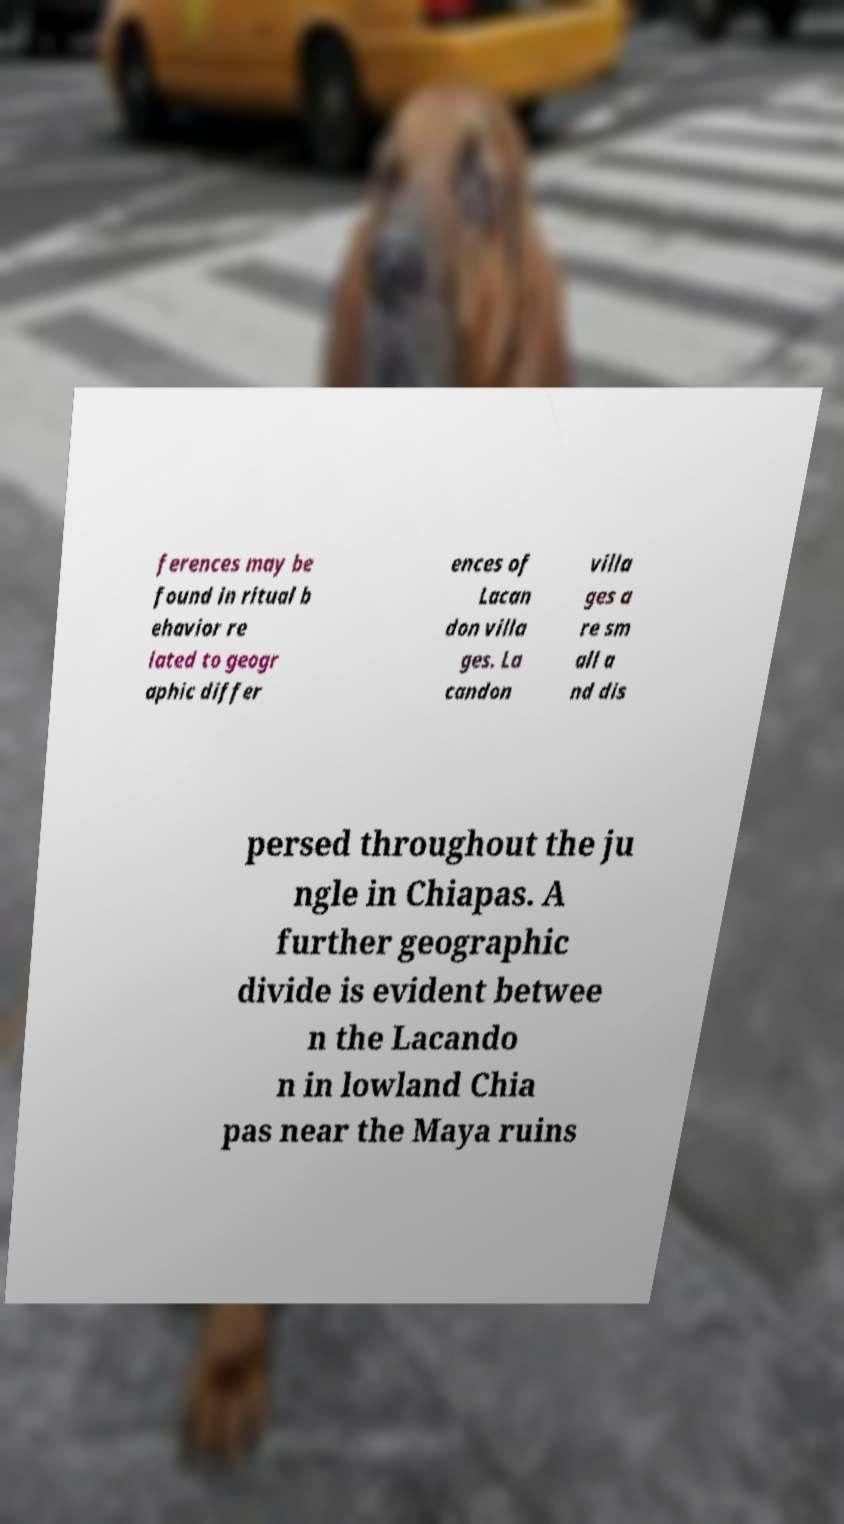For documentation purposes, I need the text within this image transcribed. Could you provide that? ferences may be found in ritual b ehavior re lated to geogr aphic differ ences of Lacan don villa ges. La candon villa ges a re sm all a nd dis persed throughout the ju ngle in Chiapas. A further geographic divide is evident betwee n the Lacando n in lowland Chia pas near the Maya ruins 